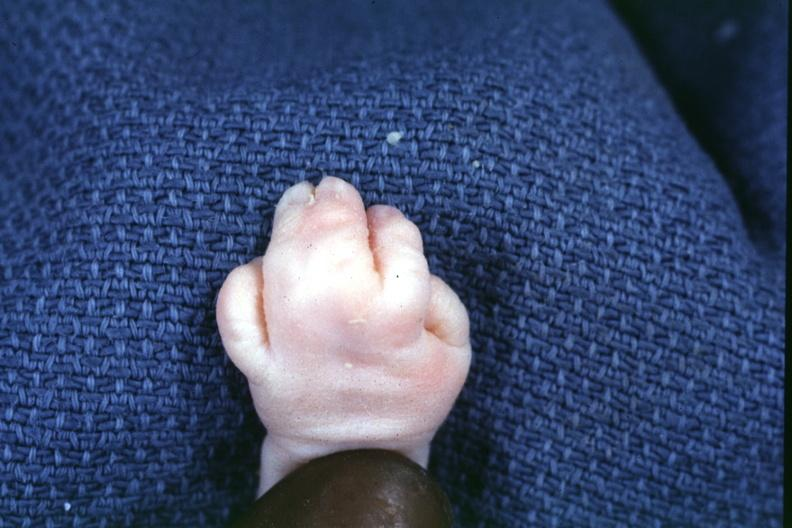re intraductal lesions present?
Answer the question using a single word or phrase. No 